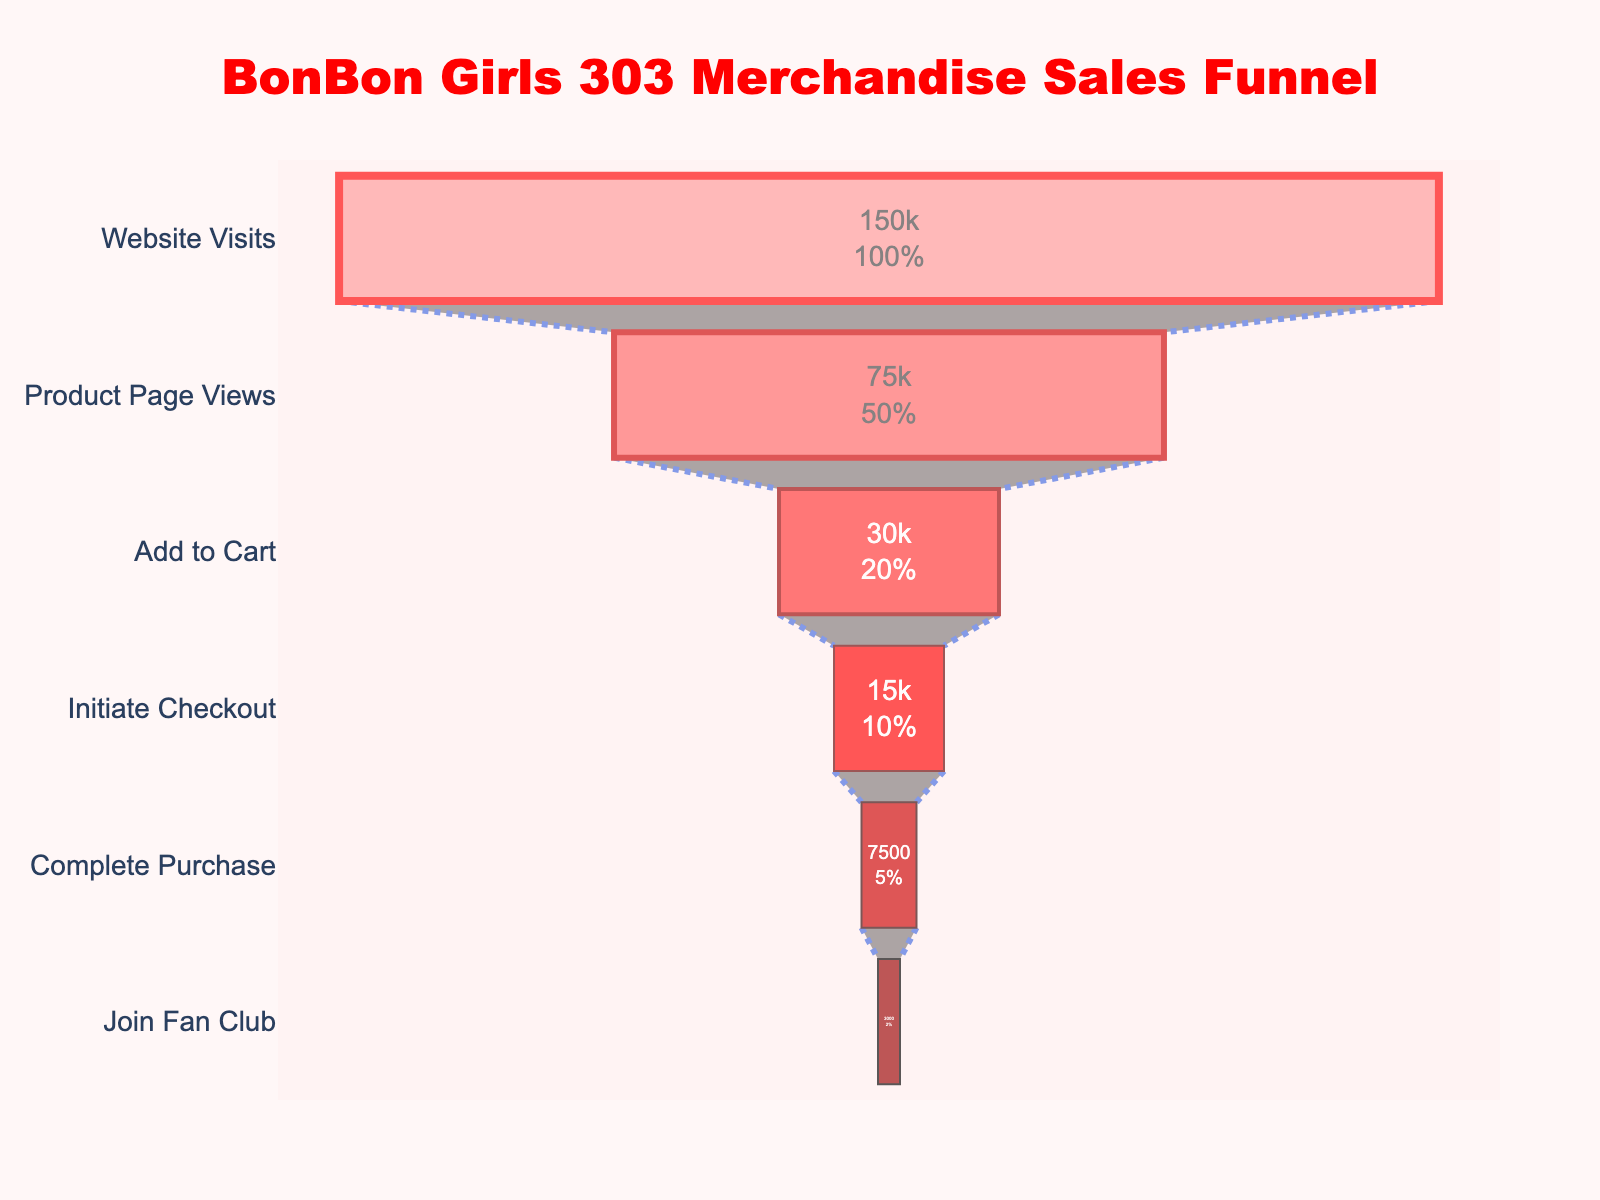what is the title of the figure? The title is displayed at the top center of the figure in bold, red, and large font. It reads "BonBon Girls 303 Merchandise Sales Funnel."
Answer: BonBon Girls 303 Merchandise Sales Funnel what is the smallest number of users in this sales funnel? To find the smallest number of users, look at the values from top to bottom of the funnel. The smallest value is at the bottom, which is 3,000 users at the "Join Fan Club" stage.
Answer: 3,000 which stage has the highest number of users? The highest number of users is typically found at the top of the funnel. In this chart, the "Website Visits" stage has the highest value of 150,000 users.
Answer: Website Visits how many stages are there in the funnel? The funnel chart shows different levels of user progression labeled from top to bottom. Counting the stages, we get six: "Website Visits," "Product Page Views," "Add to Cart," "Initiate Checkout," "Complete Purchase," and "Join Fan Club."
Answer: 6 how many users drop off between "Product Page Views" and "Add to Cart"? To find the drop-off, subtract the number of users in "Add to Cart" from the "Product Page Views" stage: 75,000 - 30,000 = 45,000.
Answer: 45,000 what is the percentage of users who complete a purchase out of those who initiate checkout? The percentage is calculated by dividing the number of users who complete a purchase by the number of users who initiate checkout and multiplying by 100: (7,500 / 15,000) * 100 = 50%.
Answer: 50% compare the number of users at the "Initiate Checkout" stage and the "Join Fan Club" stage. How much more is one than the other? To compare, subtract the number of users in "Join Fan Club" from the "Initiate Checkout" stage: 15,000 - 3,000 = 12,000 users.
Answer: 12,000 what percentage of users add merchandise to their cart after viewing the product page? The percentage is calculated by dividing the number of users who added to cart by the number of users who viewed the product page and multiplying by 100: (30,000 / 75,000) * 100 = 40%.
Answer: 40% 